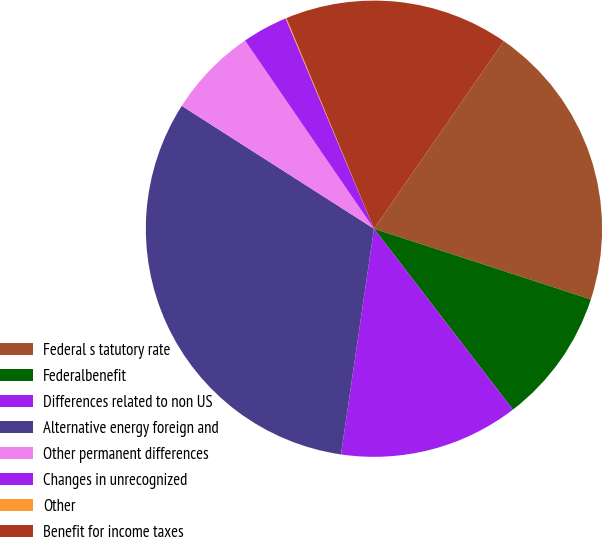Convert chart. <chart><loc_0><loc_0><loc_500><loc_500><pie_chart><fcel>Federal s tatutory rate<fcel>Federalbenefit<fcel>Differences related to non US<fcel>Alternative energy foreign and<fcel>Other permanent differences<fcel>Changes in unrecognized<fcel>Other<fcel>Benefit for income taxes<nl><fcel>20.38%<fcel>9.56%<fcel>12.73%<fcel>31.74%<fcel>6.39%<fcel>3.23%<fcel>0.06%<fcel>15.9%<nl></chart> 